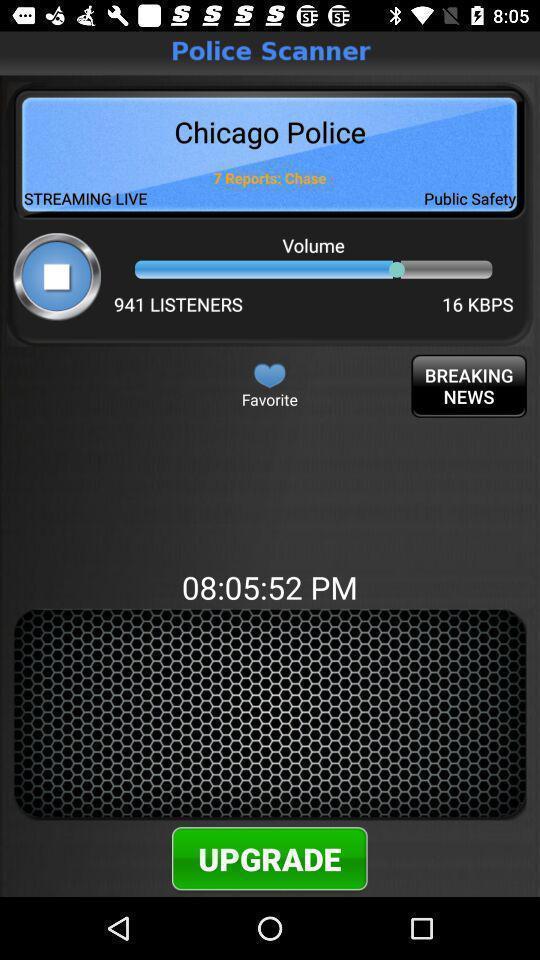What is the overall content of this screenshot? Page shows the upgrade option of scanner on news app. 